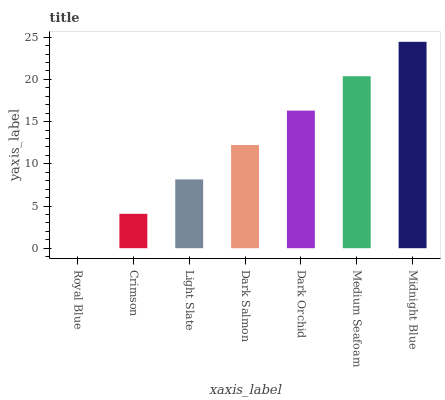Is Royal Blue the minimum?
Answer yes or no. Yes. Is Midnight Blue the maximum?
Answer yes or no. Yes. Is Crimson the minimum?
Answer yes or no. No. Is Crimson the maximum?
Answer yes or no. No. Is Crimson greater than Royal Blue?
Answer yes or no. Yes. Is Royal Blue less than Crimson?
Answer yes or no. Yes. Is Royal Blue greater than Crimson?
Answer yes or no. No. Is Crimson less than Royal Blue?
Answer yes or no. No. Is Dark Salmon the high median?
Answer yes or no. Yes. Is Dark Salmon the low median?
Answer yes or no. Yes. Is Dark Orchid the high median?
Answer yes or no. No. Is Royal Blue the low median?
Answer yes or no. No. 